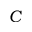Convert formula to latex. <formula><loc_0><loc_0><loc_500><loc_500>C</formula> 